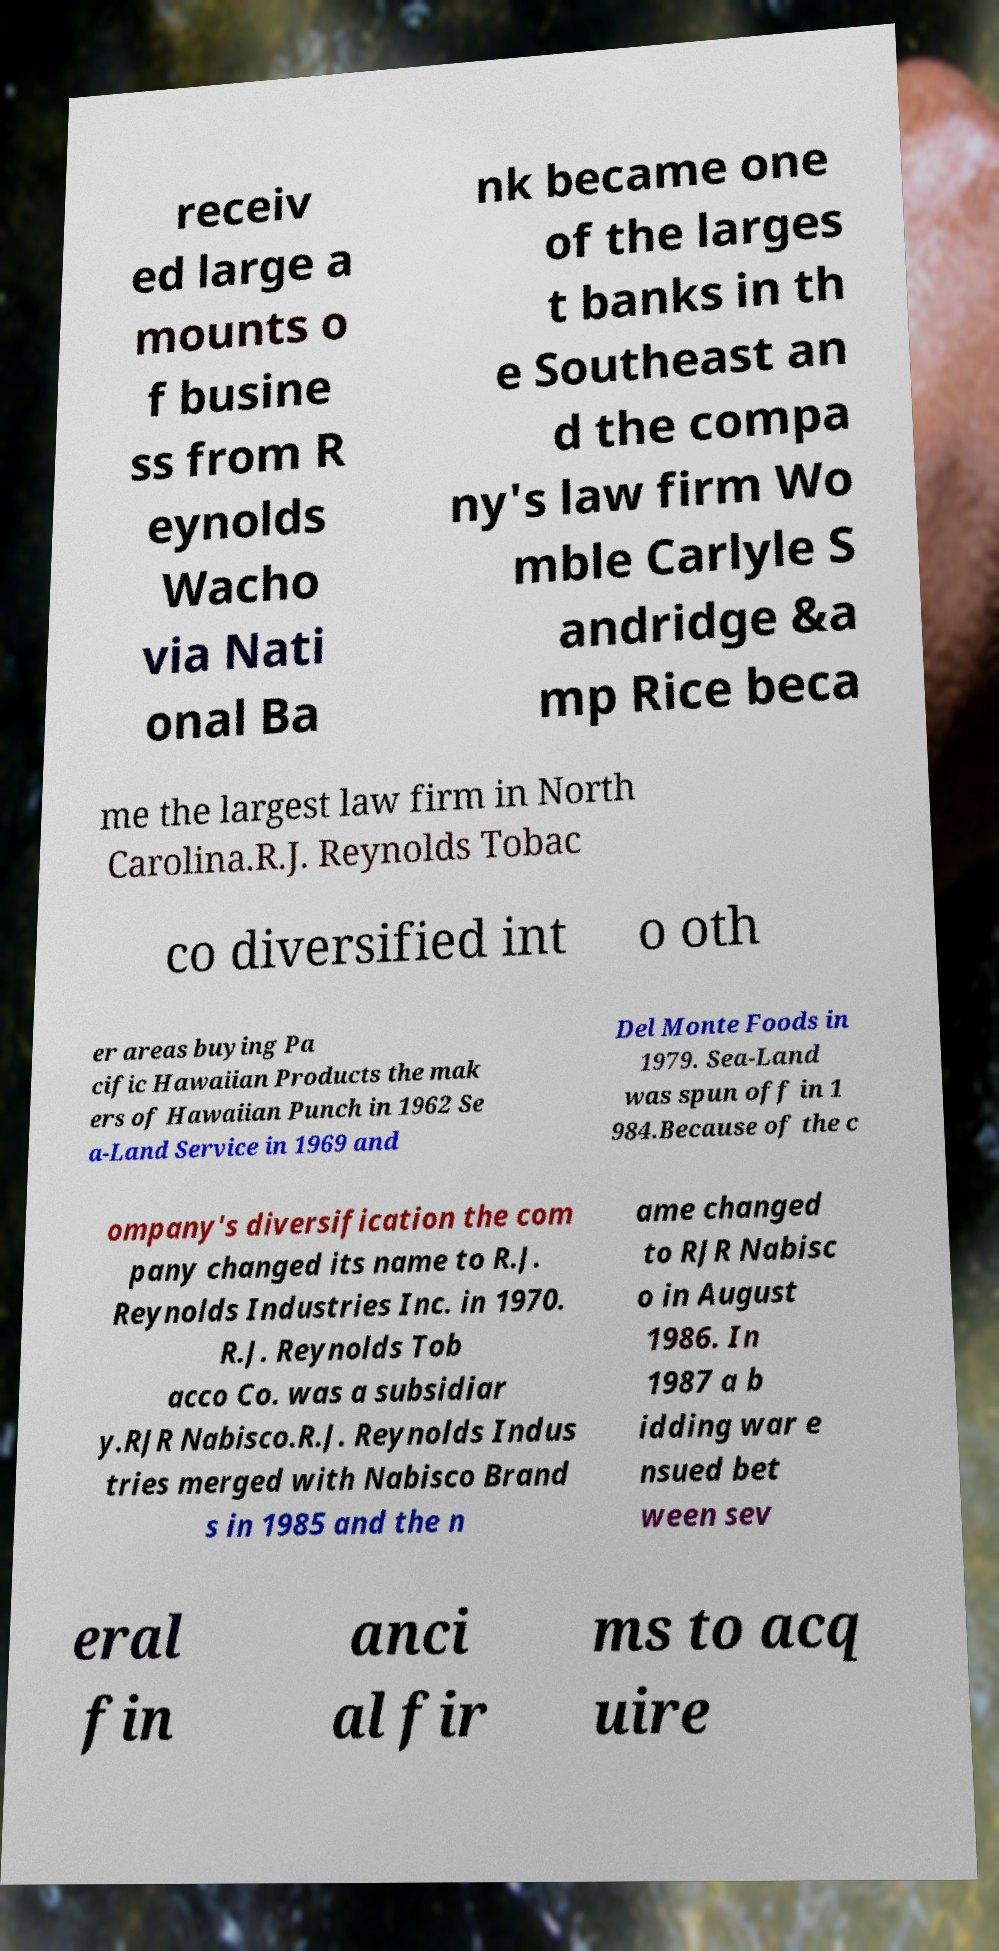Can you accurately transcribe the text from the provided image for me? receiv ed large a mounts o f busine ss from R eynolds Wacho via Nati onal Ba nk became one of the larges t banks in th e Southeast an d the compa ny's law firm Wo mble Carlyle S andridge &a mp Rice beca me the largest law firm in North Carolina.R.J. Reynolds Tobac co diversified int o oth er areas buying Pa cific Hawaiian Products the mak ers of Hawaiian Punch in 1962 Se a-Land Service in 1969 and Del Monte Foods in 1979. Sea-Land was spun off in 1 984.Because of the c ompany's diversification the com pany changed its name to R.J. Reynolds Industries Inc. in 1970. R.J. Reynolds Tob acco Co. was a subsidiar y.RJR Nabisco.R.J. Reynolds Indus tries merged with Nabisco Brand s in 1985 and the n ame changed to RJR Nabisc o in August 1986. In 1987 a b idding war e nsued bet ween sev eral fin anci al fir ms to acq uire 